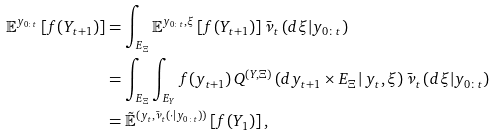Convert formula to latex. <formula><loc_0><loc_0><loc_500><loc_500>\mathbb { E } ^ { y _ { 0 \colon t } } \left [ f ( Y _ { t + 1 } ) \right ] & = \int _ { E _ { \Xi } } \mathbb { E } ^ { y _ { 0 \colon t } , \xi } \left [ f ( Y _ { t + 1 } ) \right ] \bar { \nu } _ { t } \left ( d \xi | y _ { 0 \colon t } \right ) \\ & = \int _ { E _ { \Xi } } \int _ { E _ { Y } } f ( y _ { t + 1 } ) \, Q ^ { ( Y , \Xi ) } \left ( d y _ { t + 1 } \times E _ { \Xi } \, | \, y _ { t } , \xi \right ) \bar { \nu } _ { t } \left ( d \xi | y _ { 0 \colon t } \right ) \\ & = \tilde { \mathbb { E } } ^ { ( y _ { t } , \bar { \nu } _ { t } ( \cdot | y _ { 0 \colon t } ) ) } \left [ f ( Y _ { 1 } ) \right ] ,</formula> 